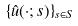Convert formula to latex. <formula><loc_0><loc_0><loc_500><loc_500>\{ \hat { u } ( \cdot ; s ) \} _ { s \in S }</formula> 